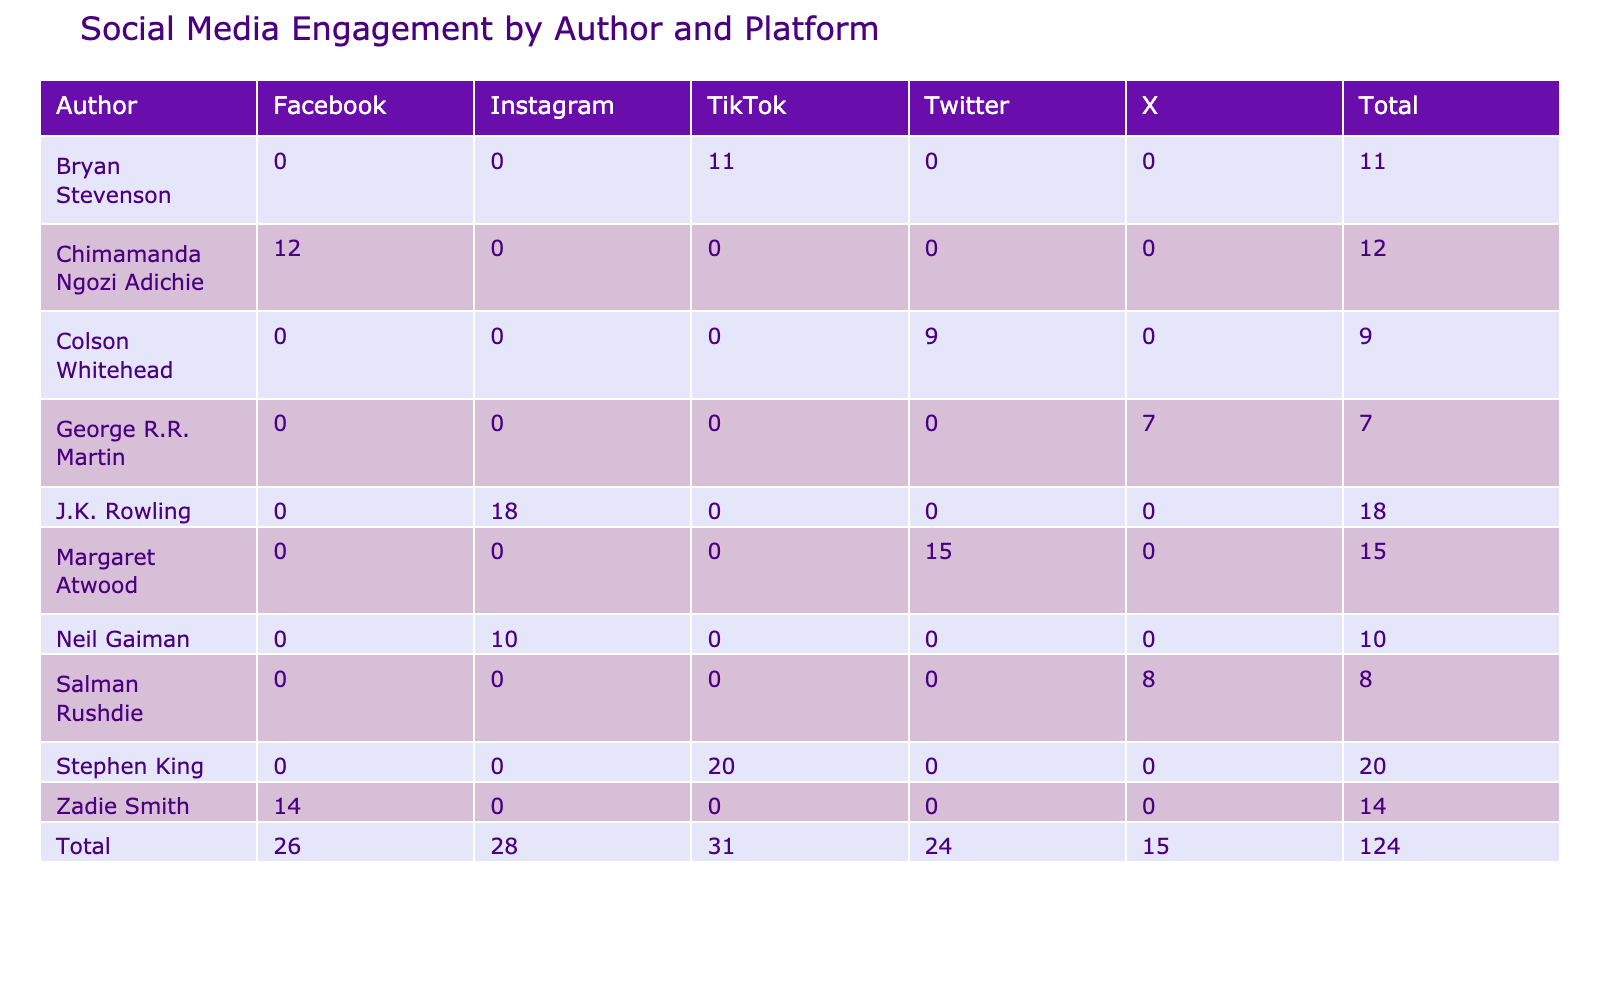What is the total number of posts made by Stephen King across all platforms? To find the total number of posts made by Stephen King, refer to the table and locate his row. He has 20 posts on TikTok, and there are no posts listed for him on other platforms. Thus, his total post count is simply 20.
Answer: 20 Which author received the highest number of likes on their posts? By examining the likes column, the highest number of likes is 1500, which corresponds to Stephen King on TikTok. Therefore, he is the author with the highest likes.
Answer: Stephen King What is the average number of comments across all authors on Instagram? The comments for each author on Instagram are: Neil Gaiman (60), J.K. Rowling (55). Adding them yields 115 comments. There are 2 authors, so the average is 115/2 = 57.5.
Answer: 57.5 Did J.K. Rowling receive more shares than Chimamanda Ngozi Adichie? Looking at the shares, J.K. Rowling has 350 shares, while Chimamanda Ngozi Adichie has 250 shares. Since 350 is greater than 250, the answer is yes.
Answer: Yes Which platform had the least engagement when combining likes, shares, and comments for Salman Rushdie? For Salman Rushdie on X, likes are 600, shares are 200, and comments are 25. Adding these gives 600 + 200 + 25 = 825. This is the least engagement compared to other authors' platform totals when analyzed.
Answer: 825 What is the total number of shares across all platforms for authors on Facebook? For Facebook, the share counts are: Chimamanda Ngozi Adichie (250) and Zadie Smith (290). Adding these gives a total of 250 + 290 = 540 shares across these authors.
Answer: 540 How many total engagements (likes, shares, comments) did Colson Whitehead achieve across Twitter? Colson Whitehead has 700 likes, 150 shares, and 20 comments on Twitter. Adding these three values: 700 + 150 + 20 = 870, gives the total engagement for him on that platform.
Answer: 870 Is the combined total of posts made by Zadie Smith and Colson Whitehead greater than that of Margaret Atwood? Zadie Smith has 14 posts on Facebook and Colson Whitehead has 9 posts on Twitter, giving a combined total of 14 + 9 = 23 posts. Margaret Atwood has 15 posts on Twitter. Since 23 is greater than 15, the answer is yes.
Answer: Yes 